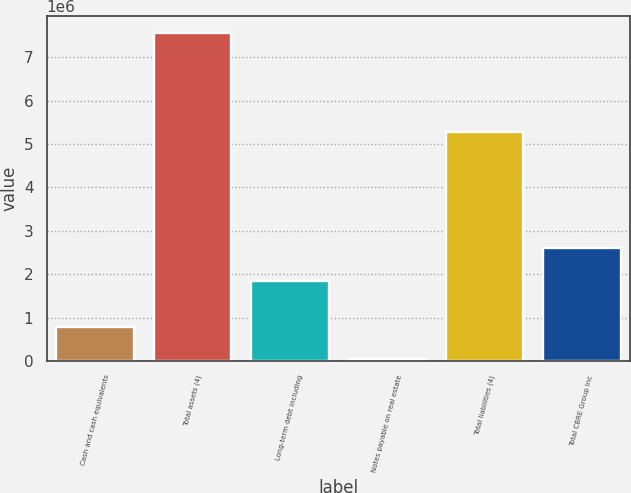Convert chart to OTSL. <chart><loc_0><loc_0><loc_500><loc_500><bar_chart><fcel>Cash and cash equivalents<fcel>Total assets (4)<fcel>Long-term debt including<fcel>Notes payable on real estate<fcel>Total liabilities (4)<fcel>Total CBRE Group Inc<nl><fcel>794102<fcel>7.56801e+06<fcel>1.85101e+06<fcel>41445<fcel>5.26661e+06<fcel>2.60367e+06<nl></chart> 